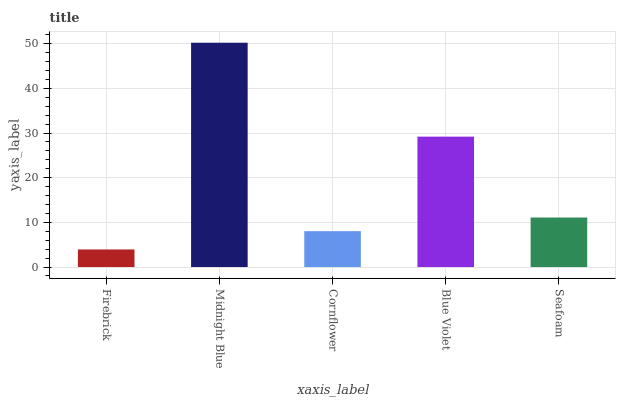Is Firebrick the minimum?
Answer yes or no. Yes. Is Midnight Blue the maximum?
Answer yes or no. Yes. Is Cornflower the minimum?
Answer yes or no. No. Is Cornflower the maximum?
Answer yes or no. No. Is Midnight Blue greater than Cornflower?
Answer yes or no. Yes. Is Cornflower less than Midnight Blue?
Answer yes or no. Yes. Is Cornflower greater than Midnight Blue?
Answer yes or no. No. Is Midnight Blue less than Cornflower?
Answer yes or no. No. Is Seafoam the high median?
Answer yes or no. Yes. Is Seafoam the low median?
Answer yes or no. Yes. Is Firebrick the high median?
Answer yes or no. No. Is Blue Violet the low median?
Answer yes or no. No. 